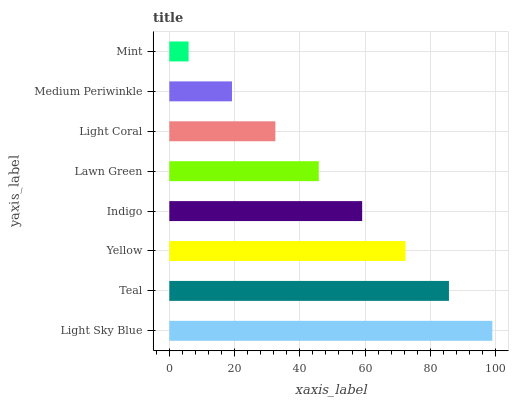Is Mint the minimum?
Answer yes or no. Yes. Is Light Sky Blue the maximum?
Answer yes or no. Yes. Is Teal the minimum?
Answer yes or no. No. Is Teal the maximum?
Answer yes or no. No. Is Light Sky Blue greater than Teal?
Answer yes or no. Yes. Is Teal less than Light Sky Blue?
Answer yes or no. Yes. Is Teal greater than Light Sky Blue?
Answer yes or no. No. Is Light Sky Blue less than Teal?
Answer yes or no. No. Is Indigo the high median?
Answer yes or no. Yes. Is Lawn Green the low median?
Answer yes or no. Yes. Is Teal the high median?
Answer yes or no. No. Is Teal the low median?
Answer yes or no. No. 